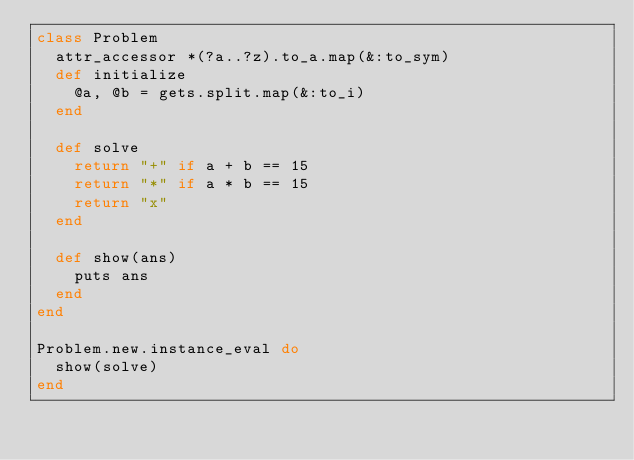Convert code to text. <code><loc_0><loc_0><loc_500><loc_500><_Ruby_>class Problem
  attr_accessor *(?a..?z).to_a.map(&:to_sym)
  def initialize
    @a, @b = gets.split.map(&:to_i)
  end

  def solve
    return "+" if a + b == 15
    return "*" if a * b == 15
    return "x"
  end

  def show(ans)
    puts ans
  end
end

Problem.new.instance_eval do
  show(solve)
end</code> 